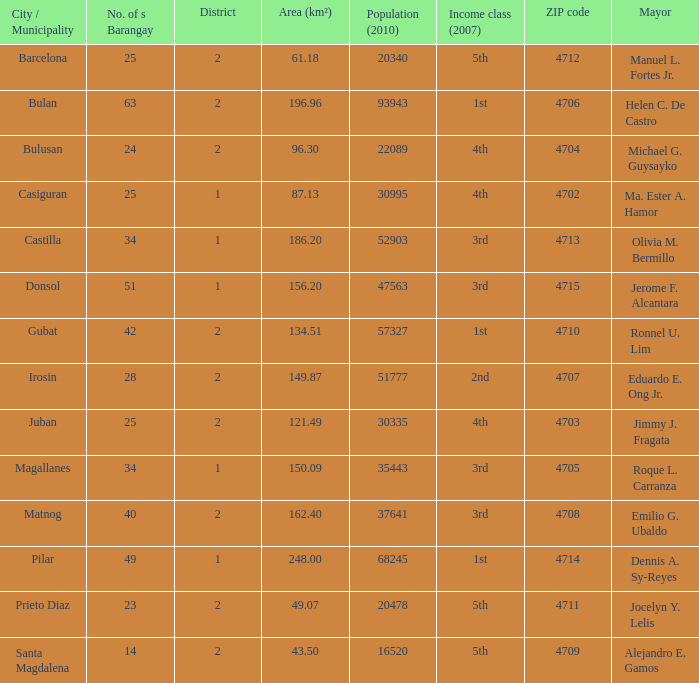What are all the metropolis / municipality where mayor is helen c. De castro Bulan. 